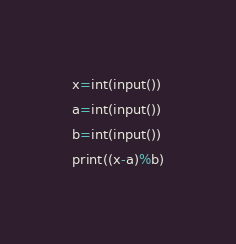<code> <loc_0><loc_0><loc_500><loc_500><_Python_>x=int(input())
a=int(input())
b=int(input())
print((x-a)%b)</code> 